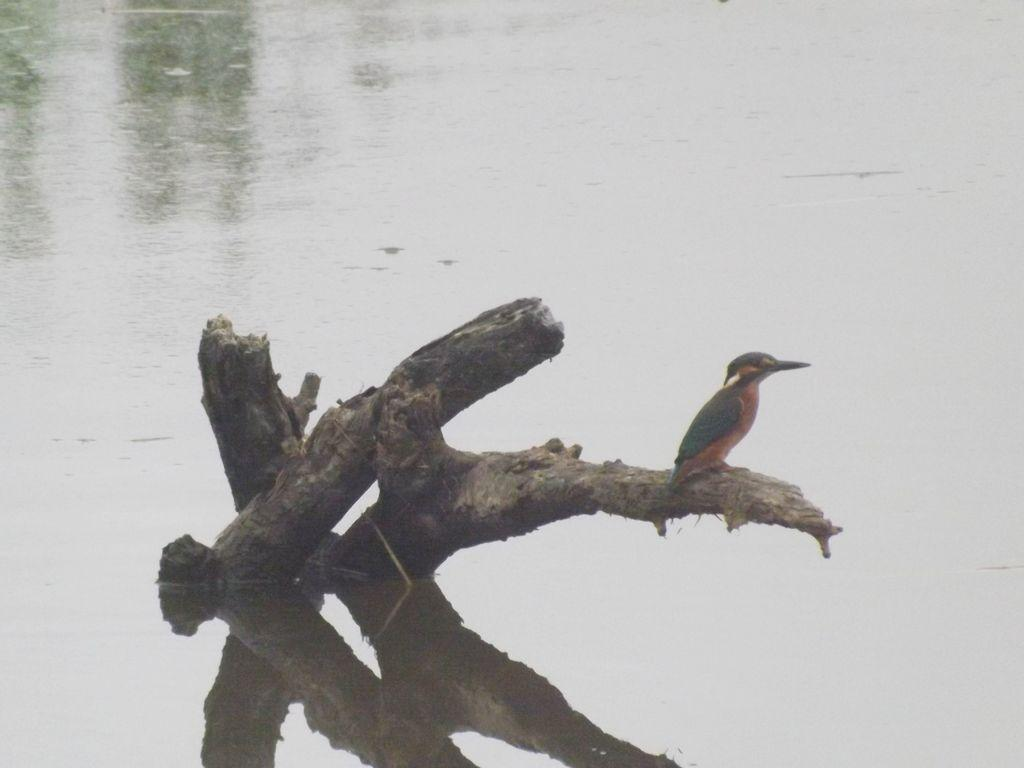What type of animal can be seen in the image? There is a bird in the image. Where is the bird located? The bird is standing on a branch. What is the bird standing on? The bird is standing on a branch. What can be seen around the branch? There is water around the branch. What type of bread is the bird holding in its beak in the image? There is no bread present in the image; the bird is standing on a branch with water around it. 